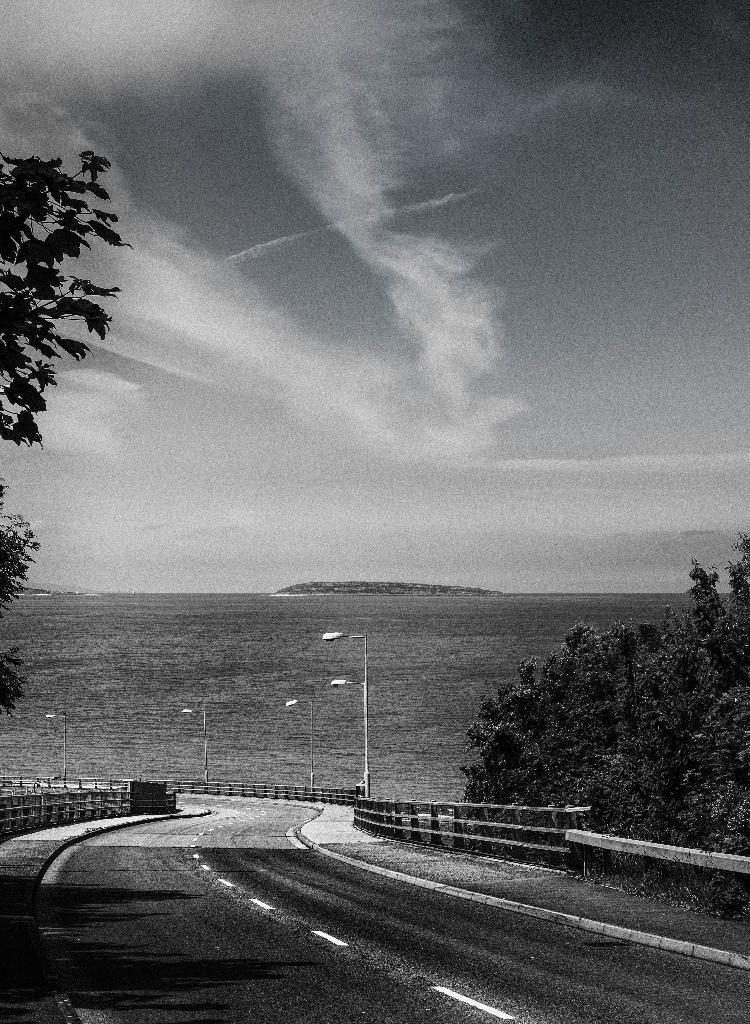Please provide a concise description of this image. In this image there is sky, there is sea, there are street lights, there are poles, there are trees truncated towards the right of the image, there are trees truncated towards the left of the image, there is fencing, there is a road. 